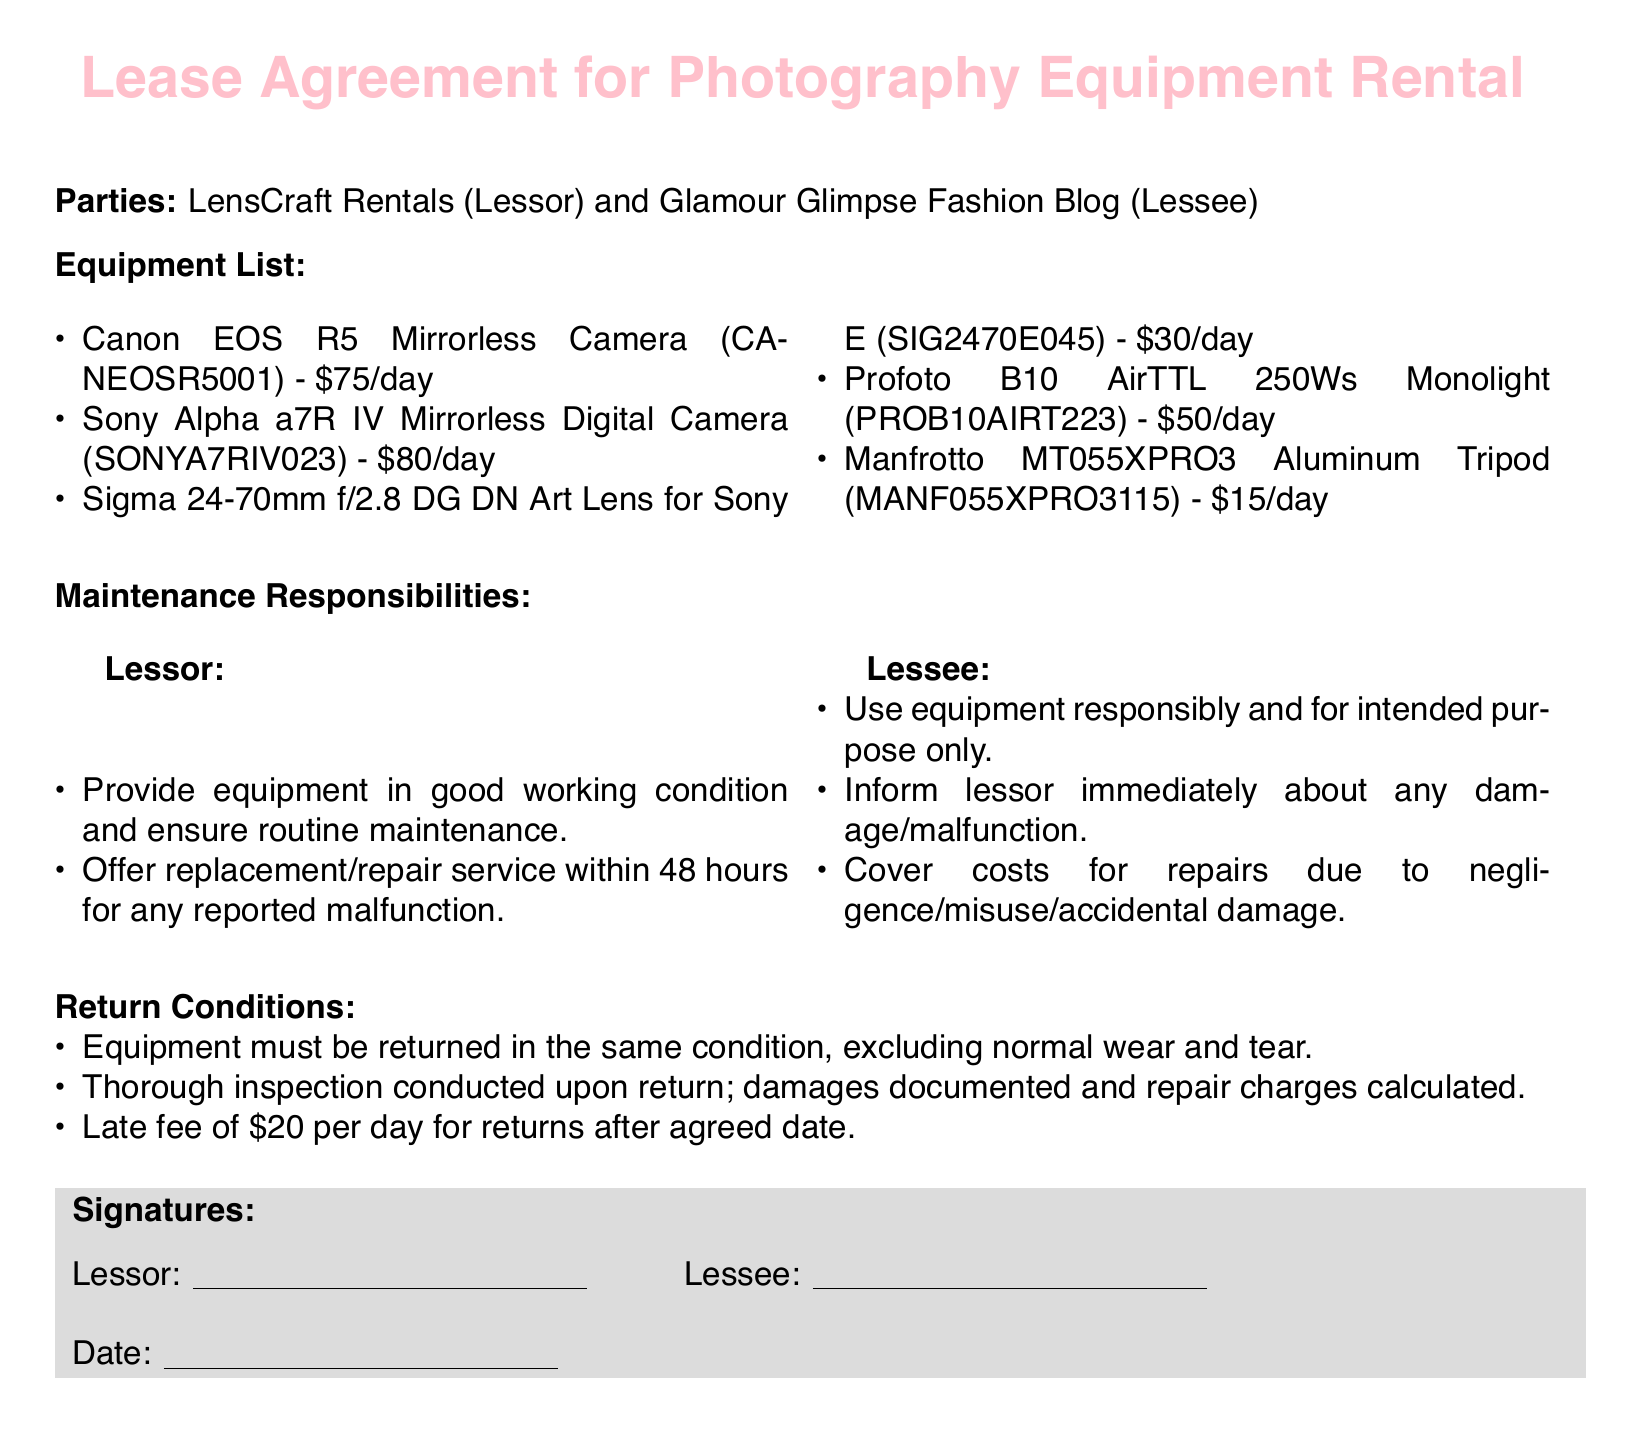What is the name of the Lessor? The Lessor is identified as LensCraft Rentals in the document.
Answer: LensCraft Rentals What is the rental price for the Canon EOS R5 camera? The rental price for the Canon EOS R5 camera is specified in the equipment list.
Answer: $75/day What are the Lessee's responsibilities for maintenance? The Lessee's responsibilities are detailed in the maintenance section, specifying their obligations.
Answer: Use equipment responsibly and inform lessor about damage What is the late fee for returning equipment after the agreed date? The document states the specific late fee amount for late returns.
Answer: $20 per day How long does the Lessor have to provide a replacement for malfunctioning equipment? The document specifies the time frame for providing a replacement in the maintenance section.
Answer: 48 hours What must be done before returning the equipment? The document mentions the condition and process for returning equipment clearly.
Answer: Thorough inspection conducted What is one consequence of negligent damage to the equipment? The Lessee must bear the costs for certain types of damage, as outlined in the maintenance section.
Answer: Cover costs for repairs What type of equipment is included in the rental? The equipment list enumerates specific photography equipment available for rent.
Answer: Cameras and lenses What should be excluded from the condition assessment upon return? The document clarifies what is excluded from the condition assessment during returns.
Answer: Normal wear and tear 